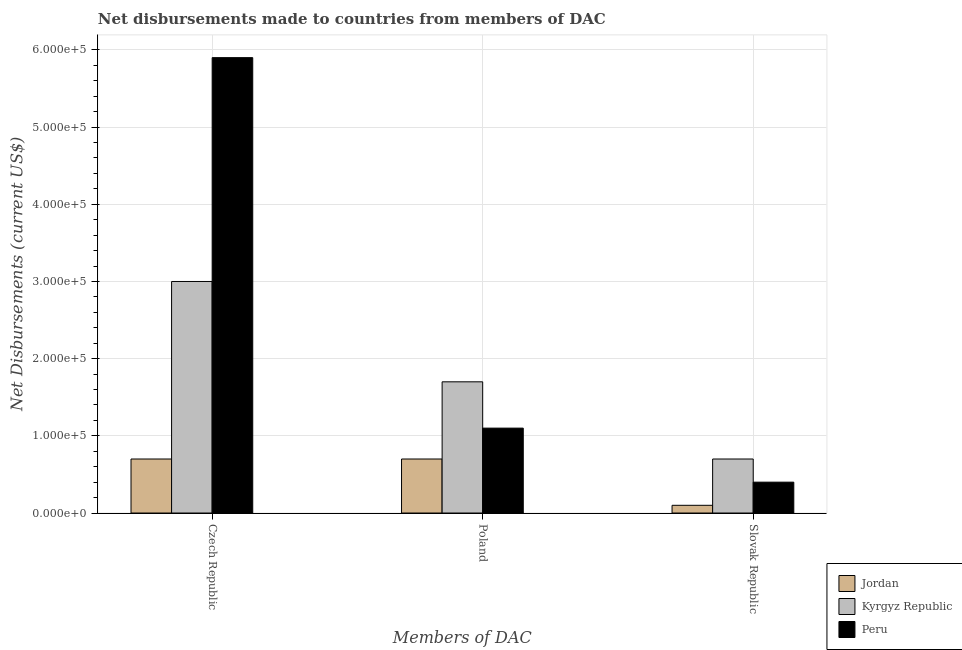Are the number of bars on each tick of the X-axis equal?
Your answer should be compact. Yes. How many bars are there on the 1st tick from the right?
Offer a terse response. 3. What is the label of the 3rd group of bars from the left?
Give a very brief answer. Slovak Republic. What is the net disbursements made by slovak republic in Jordan?
Make the answer very short. 10000. Across all countries, what is the maximum net disbursements made by poland?
Provide a short and direct response. 1.70e+05. Across all countries, what is the minimum net disbursements made by slovak republic?
Offer a terse response. 10000. In which country was the net disbursements made by slovak republic maximum?
Ensure brevity in your answer.  Kyrgyz Republic. In which country was the net disbursements made by slovak republic minimum?
Keep it short and to the point. Jordan. What is the total net disbursements made by czech republic in the graph?
Keep it short and to the point. 9.60e+05. What is the difference between the net disbursements made by poland in Kyrgyz Republic and that in Peru?
Your answer should be very brief. 6.00e+04. What is the difference between the net disbursements made by poland in Peru and the net disbursements made by czech republic in Jordan?
Keep it short and to the point. 4.00e+04. What is the average net disbursements made by poland per country?
Your answer should be very brief. 1.17e+05. What is the difference between the net disbursements made by slovak republic and net disbursements made by czech republic in Peru?
Your response must be concise. -5.50e+05. In how many countries, is the net disbursements made by poland greater than 340000 US$?
Your answer should be compact. 0. What is the difference between the highest and the lowest net disbursements made by czech republic?
Give a very brief answer. 5.20e+05. In how many countries, is the net disbursements made by poland greater than the average net disbursements made by poland taken over all countries?
Your response must be concise. 1. What does the 3rd bar from the left in Slovak Republic represents?
Provide a short and direct response. Peru. What does the 3rd bar from the right in Poland represents?
Provide a succinct answer. Jordan. Is it the case that in every country, the sum of the net disbursements made by czech republic and net disbursements made by poland is greater than the net disbursements made by slovak republic?
Keep it short and to the point. Yes. How many countries are there in the graph?
Provide a succinct answer. 3. What is the difference between two consecutive major ticks on the Y-axis?
Offer a terse response. 1.00e+05. Are the values on the major ticks of Y-axis written in scientific E-notation?
Ensure brevity in your answer.  Yes. Does the graph contain any zero values?
Keep it short and to the point. No. Where does the legend appear in the graph?
Give a very brief answer. Bottom right. What is the title of the graph?
Your answer should be very brief. Net disbursements made to countries from members of DAC. Does "Vietnam" appear as one of the legend labels in the graph?
Keep it short and to the point. No. What is the label or title of the X-axis?
Your response must be concise. Members of DAC. What is the label or title of the Y-axis?
Provide a succinct answer. Net Disbursements (current US$). What is the Net Disbursements (current US$) in Peru in Czech Republic?
Provide a short and direct response. 5.90e+05. What is the Net Disbursements (current US$) in Peru in Poland?
Offer a terse response. 1.10e+05. Across all Members of DAC, what is the maximum Net Disbursements (current US$) in Jordan?
Your response must be concise. 7.00e+04. Across all Members of DAC, what is the maximum Net Disbursements (current US$) in Kyrgyz Republic?
Provide a succinct answer. 3.00e+05. Across all Members of DAC, what is the maximum Net Disbursements (current US$) in Peru?
Your answer should be compact. 5.90e+05. Across all Members of DAC, what is the minimum Net Disbursements (current US$) of Jordan?
Ensure brevity in your answer.  10000. Across all Members of DAC, what is the minimum Net Disbursements (current US$) in Kyrgyz Republic?
Your response must be concise. 7.00e+04. Across all Members of DAC, what is the minimum Net Disbursements (current US$) in Peru?
Provide a short and direct response. 4.00e+04. What is the total Net Disbursements (current US$) of Jordan in the graph?
Your answer should be very brief. 1.50e+05. What is the total Net Disbursements (current US$) in Kyrgyz Republic in the graph?
Offer a terse response. 5.40e+05. What is the total Net Disbursements (current US$) of Peru in the graph?
Give a very brief answer. 7.40e+05. What is the difference between the Net Disbursements (current US$) in Jordan in Czech Republic and that in Poland?
Ensure brevity in your answer.  0. What is the difference between the Net Disbursements (current US$) in Kyrgyz Republic in Czech Republic and that in Poland?
Your answer should be compact. 1.30e+05. What is the difference between the Net Disbursements (current US$) in Peru in Czech Republic and that in Poland?
Your answer should be very brief. 4.80e+05. What is the difference between the Net Disbursements (current US$) of Jordan in Czech Republic and that in Slovak Republic?
Keep it short and to the point. 6.00e+04. What is the difference between the Net Disbursements (current US$) of Jordan in Poland and that in Slovak Republic?
Ensure brevity in your answer.  6.00e+04. What is the difference between the Net Disbursements (current US$) of Kyrgyz Republic in Poland and that in Slovak Republic?
Your answer should be very brief. 1.00e+05. What is the difference between the Net Disbursements (current US$) of Peru in Poland and that in Slovak Republic?
Ensure brevity in your answer.  7.00e+04. What is the difference between the Net Disbursements (current US$) of Jordan in Czech Republic and the Net Disbursements (current US$) of Kyrgyz Republic in Slovak Republic?
Your response must be concise. 0. What is the difference between the Net Disbursements (current US$) of Jordan in Poland and the Net Disbursements (current US$) of Kyrgyz Republic in Slovak Republic?
Your response must be concise. 0. What is the difference between the Net Disbursements (current US$) in Jordan in Poland and the Net Disbursements (current US$) in Peru in Slovak Republic?
Your answer should be compact. 3.00e+04. What is the average Net Disbursements (current US$) of Jordan per Members of DAC?
Keep it short and to the point. 5.00e+04. What is the average Net Disbursements (current US$) in Kyrgyz Republic per Members of DAC?
Your response must be concise. 1.80e+05. What is the average Net Disbursements (current US$) of Peru per Members of DAC?
Offer a very short reply. 2.47e+05. What is the difference between the Net Disbursements (current US$) in Jordan and Net Disbursements (current US$) in Kyrgyz Republic in Czech Republic?
Provide a short and direct response. -2.30e+05. What is the difference between the Net Disbursements (current US$) of Jordan and Net Disbursements (current US$) of Peru in Czech Republic?
Your response must be concise. -5.20e+05. What is the difference between the Net Disbursements (current US$) of Kyrgyz Republic and Net Disbursements (current US$) of Peru in Czech Republic?
Your response must be concise. -2.90e+05. What is the difference between the Net Disbursements (current US$) of Jordan and Net Disbursements (current US$) of Kyrgyz Republic in Poland?
Make the answer very short. -1.00e+05. What is the difference between the Net Disbursements (current US$) of Kyrgyz Republic and Net Disbursements (current US$) of Peru in Poland?
Provide a short and direct response. 6.00e+04. What is the difference between the Net Disbursements (current US$) in Jordan and Net Disbursements (current US$) in Kyrgyz Republic in Slovak Republic?
Give a very brief answer. -6.00e+04. What is the difference between the Net Disbursements (current US$) of Jordan and Net Disbursements (current US$) of Peru in Slovak Republic?
Ensure brevity in your answer.  -3.00e+04. What is the ratio of the Net Disbursements (current US$) of Kyrgyz Republic in Czech Republic to that in Poland?
Provide a short and direct response. 1.76. What is the ratio of the Net Disbursements (current US$) of Peru in Czech Republic to that in Poland?
Offer a very short reply. 5.36. What is the ratio of the Net Disbursements (current US$) of Jordan in Czech Republic to that in Slovak Republic?
Your answer should be compact. 7. What is the ratio of the Net Disbursements (current US$) in Kyrgyz Republic in Czech Republic to that in Slovak Republic?
Ensure brevity in your answer.  4.29. What is the ratio of the Net Disbursements (current US$) of Peru in Czech Republic to that in Slovak Republic?
Your answer should be compact. 14.75. What is the ratio of the Net Disbursements (current US$) in Kyrgyz Republic in Poland to that in Slovak Republic?
Your answer should be compact. 2.43. What is the ratio of the Net Disbursements (current US$) of Peru in Poland to that in Slovak Republic?
Keep it short and to the point. 2.75. What is the difference between the highest and the second highest Net Disbursements (current US$) in Kyrgyz Republic?
Offer a very short reply. 1.30e+05. What is the difference between the highest and the second highest Net Disbursements (current US$) of Peru?
Your answer should be compact. 4.80e+05. What is the difference between the highest and the lowest Net Disbursements (current US$) of Jordan?
Provide a short and direct response. 6.00e+04. What is the difference between the highest and the lowest Net Disbursements (current US$) of Kyrgyz Republic?
Provide a short and direct response. 2.30e+05. 